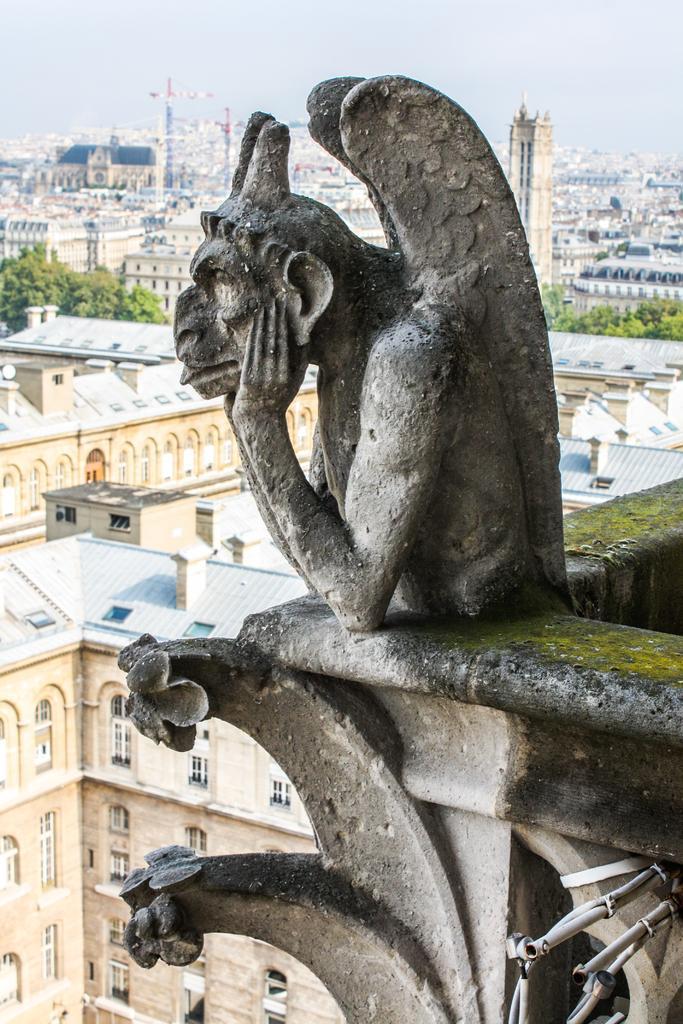Can you describe this image briefly? In this picture we can see a statue, here we can see buildings, trees and some objects and we can see sky in the background. 